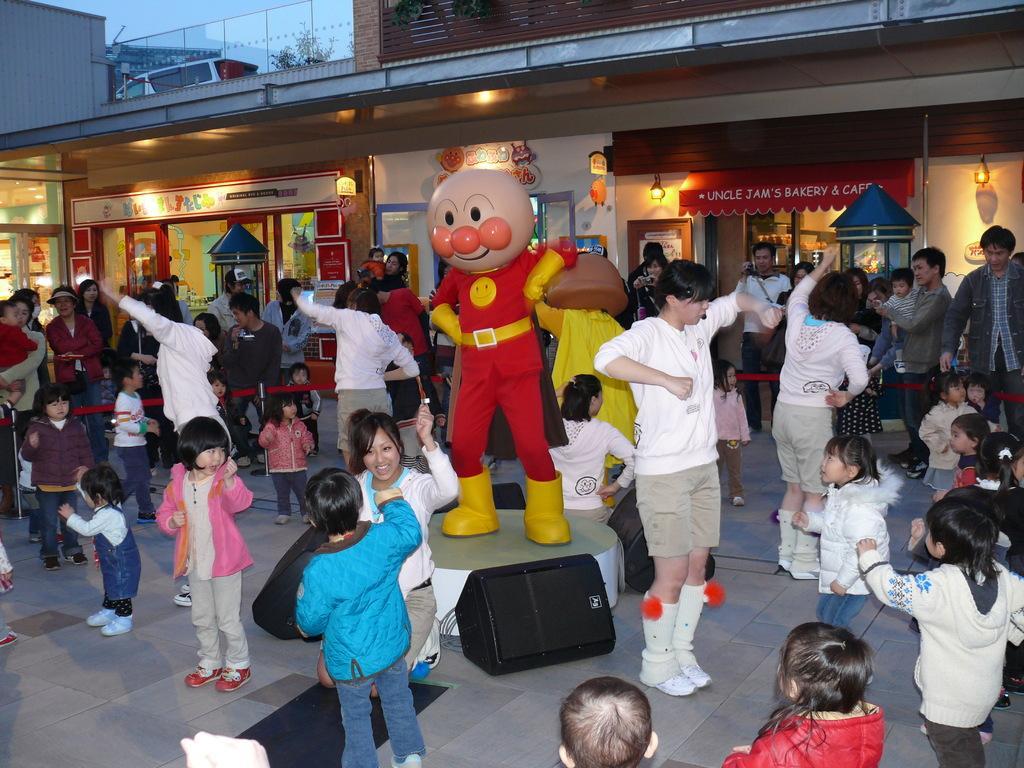Describe this image in one or two sentences. In the foreground I can see a crowd on the floor, bags and a person in a costume. In the background I can see a building, shops, lights, doors, houseplant and the sky. This image is taken may be near the shop. 